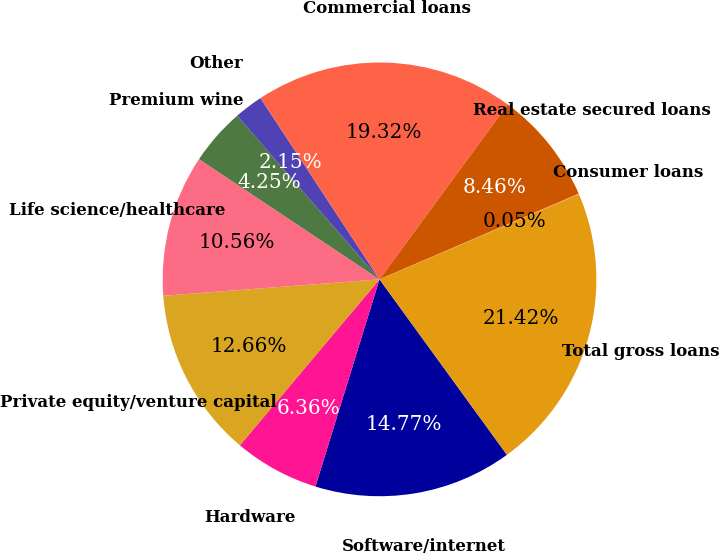<chart> <loc_0><loc_0><loc_500><loc_500><pie_chart><fcel>Software/internet<fcel>Hardware<fcel>Private equity/venture capital<fcel>Life science/healthcare<fcel>Premium wine<fcel>Other<fcel>Commercial loans<fcel>Real estate secured loans<fcel>Consumer loans<fcel>Total gross loans<nl><fcel>14.77%<fcel>6.36%<fcel>12.66%<fcel>10.56%<fcel>4.25%<fcel>2.15%<fcel>19.32%<fcel>8.46%<fcel>0.05%<fcel>21.42%<nl></chart> 